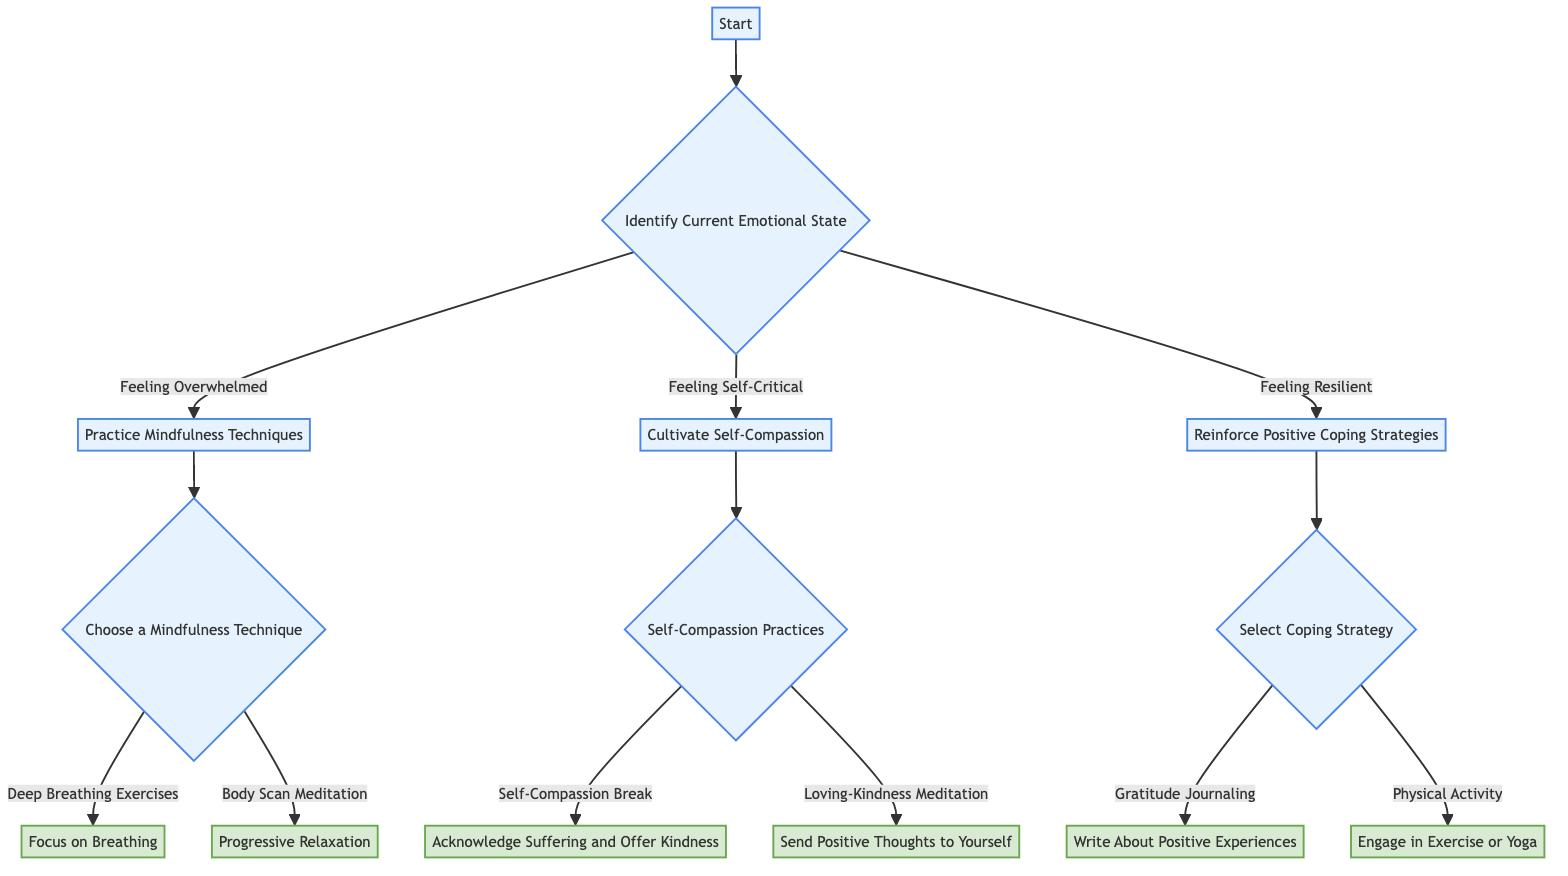What is the first decision point in the diagram? The first decision point is "Identify Current Emotional State," which branches into three options based on the individual's feelings.
Answer: Identify Current Emotional State How many options are there for the emotional state of the individual? There are three options: "Feeling Overwhelmed," "Feeling Self-Critical," and "Feeling Resilient." Each option leads to a different path in the decision tree.
Answer: 3 If someone selects "Feeling Self-Critical," what node do they reach? Selecting "Feeling Self-Critical" leads to the node "Cultivate Self-Compassion," indicating a focus on self-kindness and compassion practices.
Answer: Cultivate Self-Compassion What technique is recommended if the individual feels "Overwhelmed" and chooses "Body Scan Meditation"? If "Overwhelmed" is selected and "Body Scan Meditation" is chosen, the next action node is "Progressive Relaxation," which focuses on bodily awareness and relaxation.
Answer: Progressive Relaxation What two coping strategies can be selected if the individual feels "Resilient"? The two coping strategies available for someone feeling resilient are "Gratitude Journaling" and "Physical Activity," both promoting positive coping mechanisms.
Answer: Gratitude Journaling and Physical Activity Which self-compassion practice involves acknowledging suffering? The practice that involves acknowledging suffering is called "Self-Compassion Break," which invites individuals to recognize their struggles and respond with kindness.
Answer: Self-Compassion Break What links "Practice Mindfulness Techniques" with "Choose a Mindfulness Technique"? "Practice Mindfulness Techniques" is the action to take immediately after identifying that someone feels "Overwhelmed," leading to the next decision point "Choose a Mindfulness Technique."
Answer: Choose a Mindfulness Technique How does the decision tree categorize individuals who feel "Resilient"? The decision tree categorizes those who feel resilient under "Reinforce Positive Coping Strategies," emphasizing the importance of maintaining and enhancing coping abilities.
Answer: Reinforce Positive Coping Strategies 